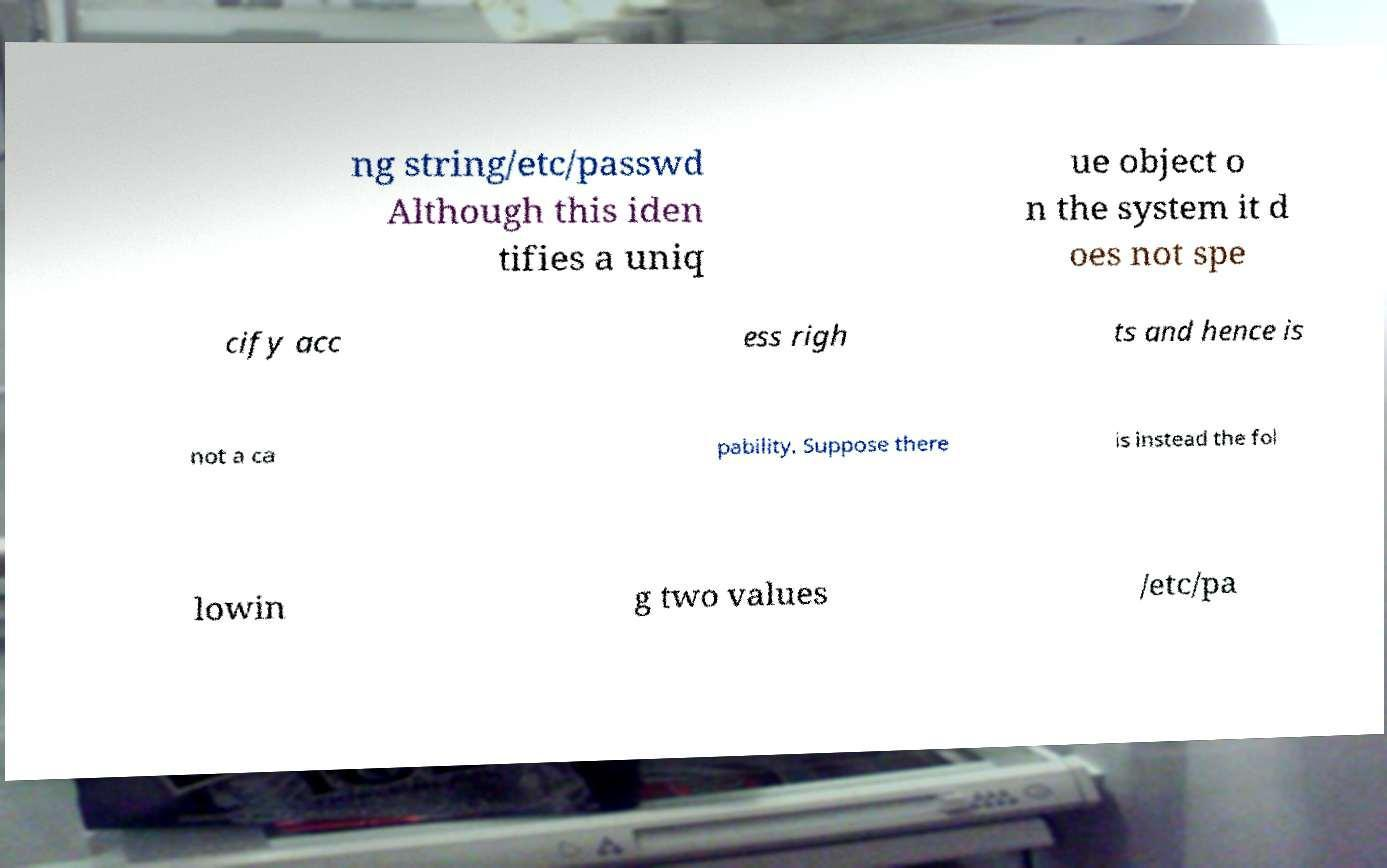For documentation purposes, I need the text within this image transcribed. Could you provide that? ng string/etc/passwd Although this iden tifies a uniq ue object o n the system it d oes not spe cify acc ess righ ts and hence is not a ca pability. Suppose there is instead the fol lowin g two values /etc/pa 